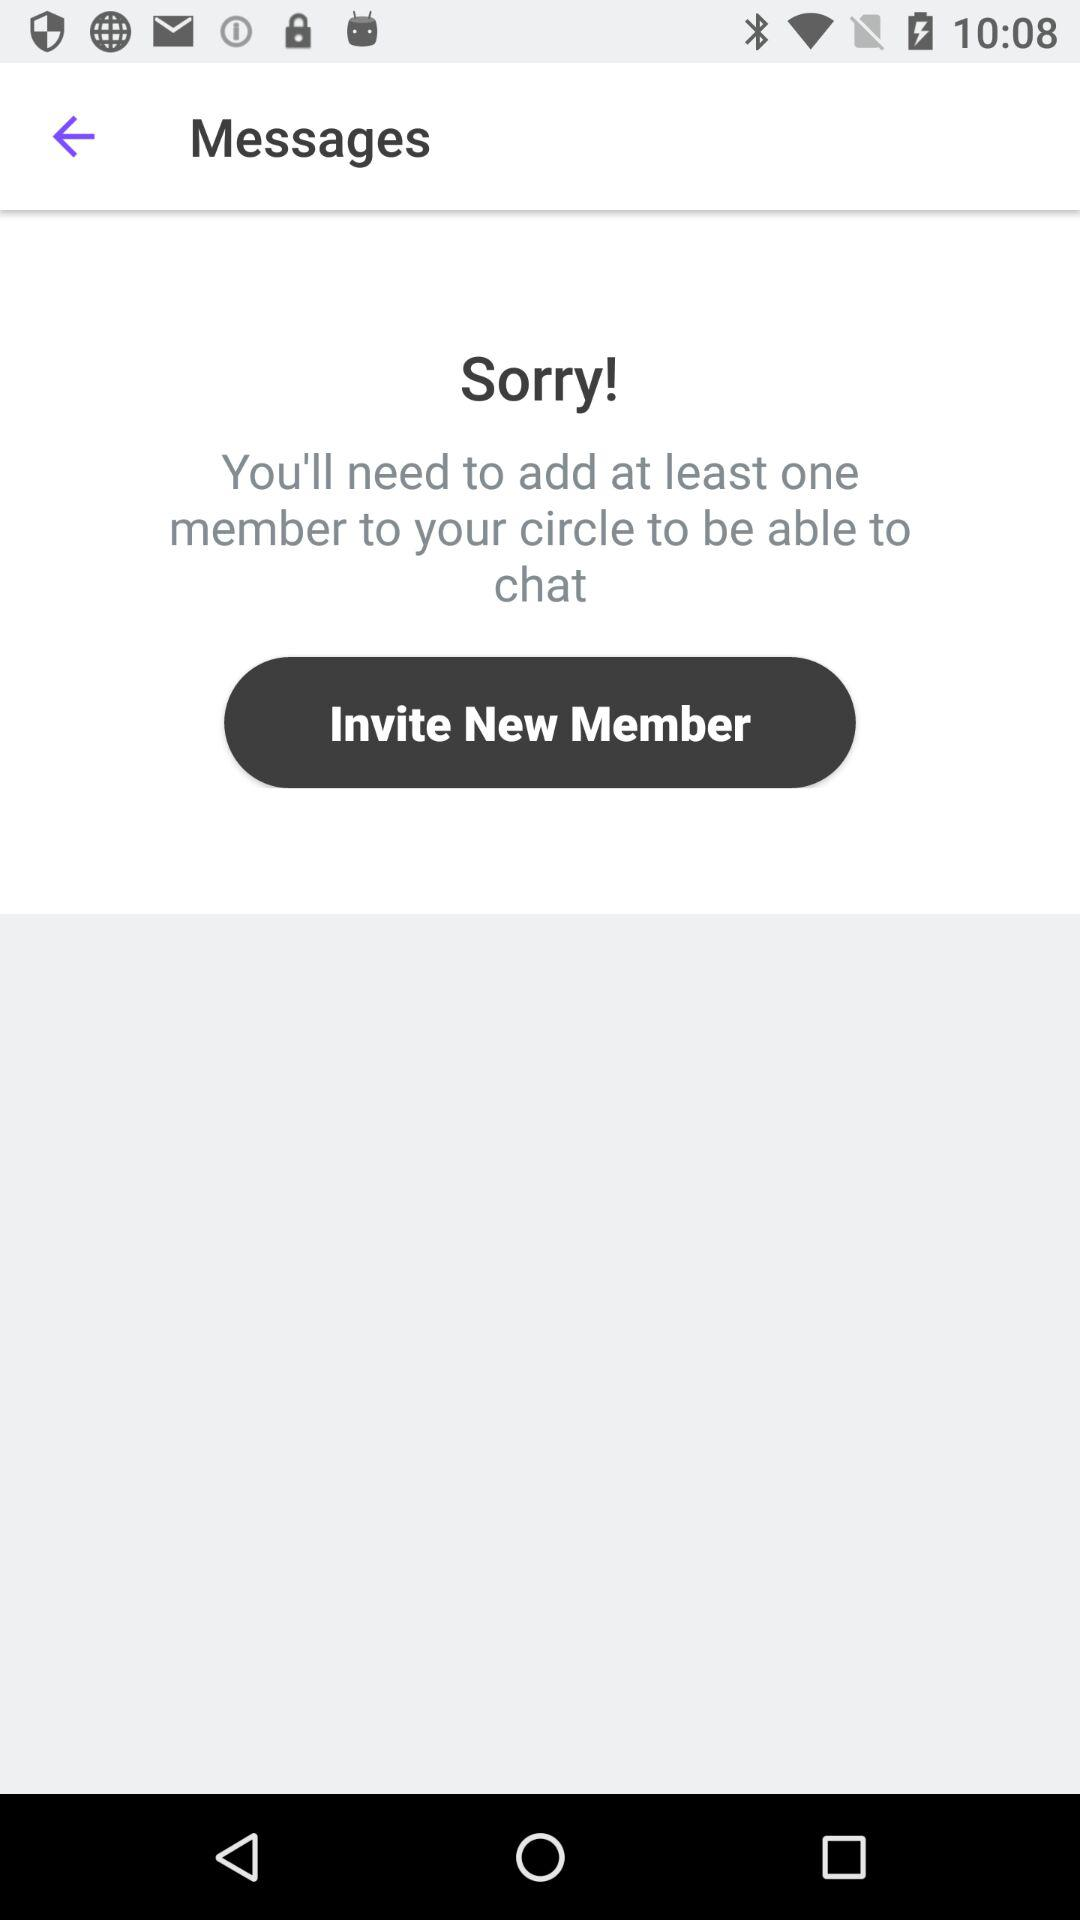How many minimum members are required to be able to chat? The minimum members required is one. 